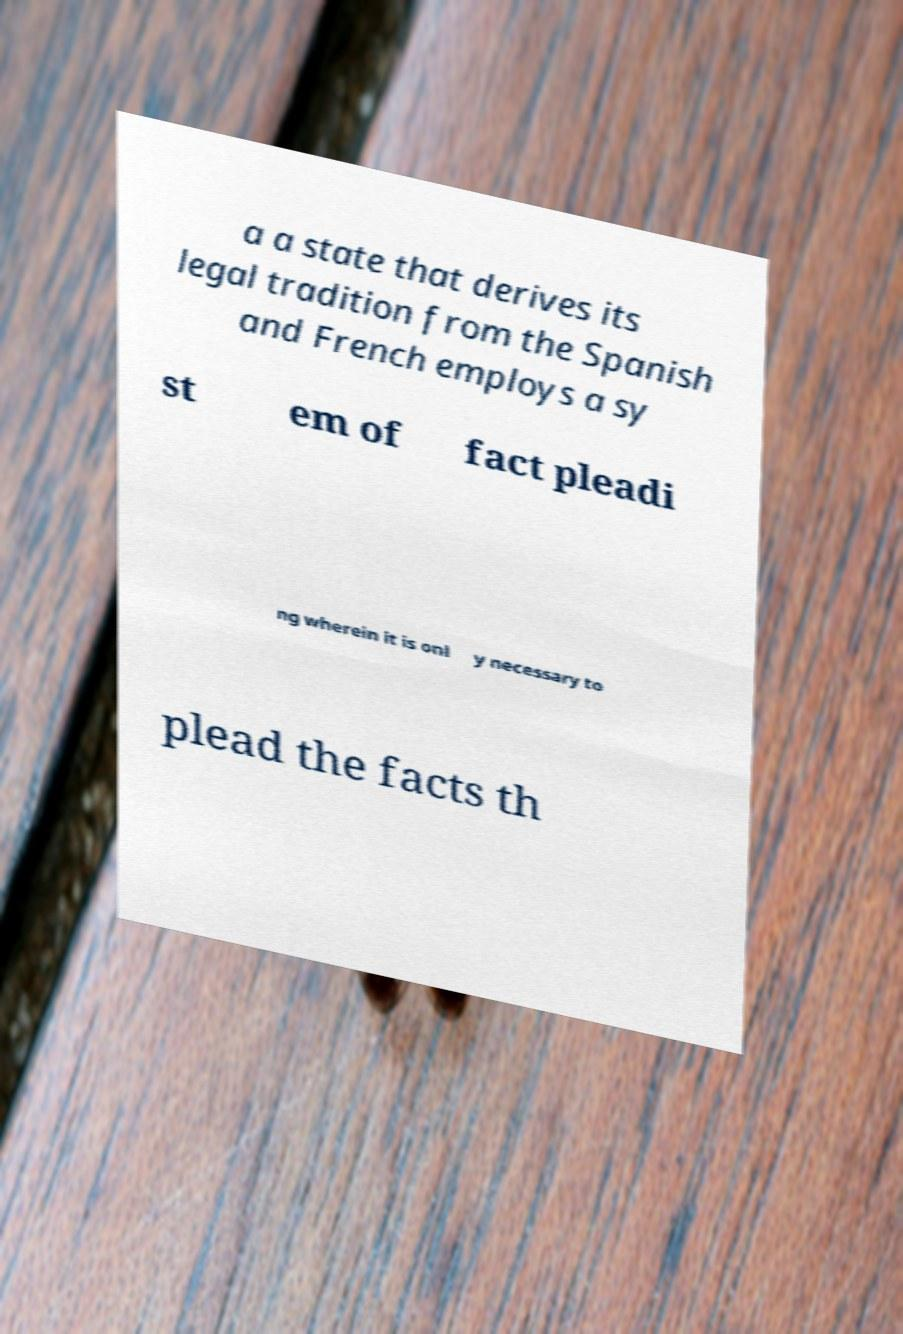For documentation purposes, I need the text within this image transcribed. Could you provide that? a a state that derives its legal tradition from the Spanish and French employs a sy st em of fact pleadi ng wherein it is onl y necessary to plead the facts th 